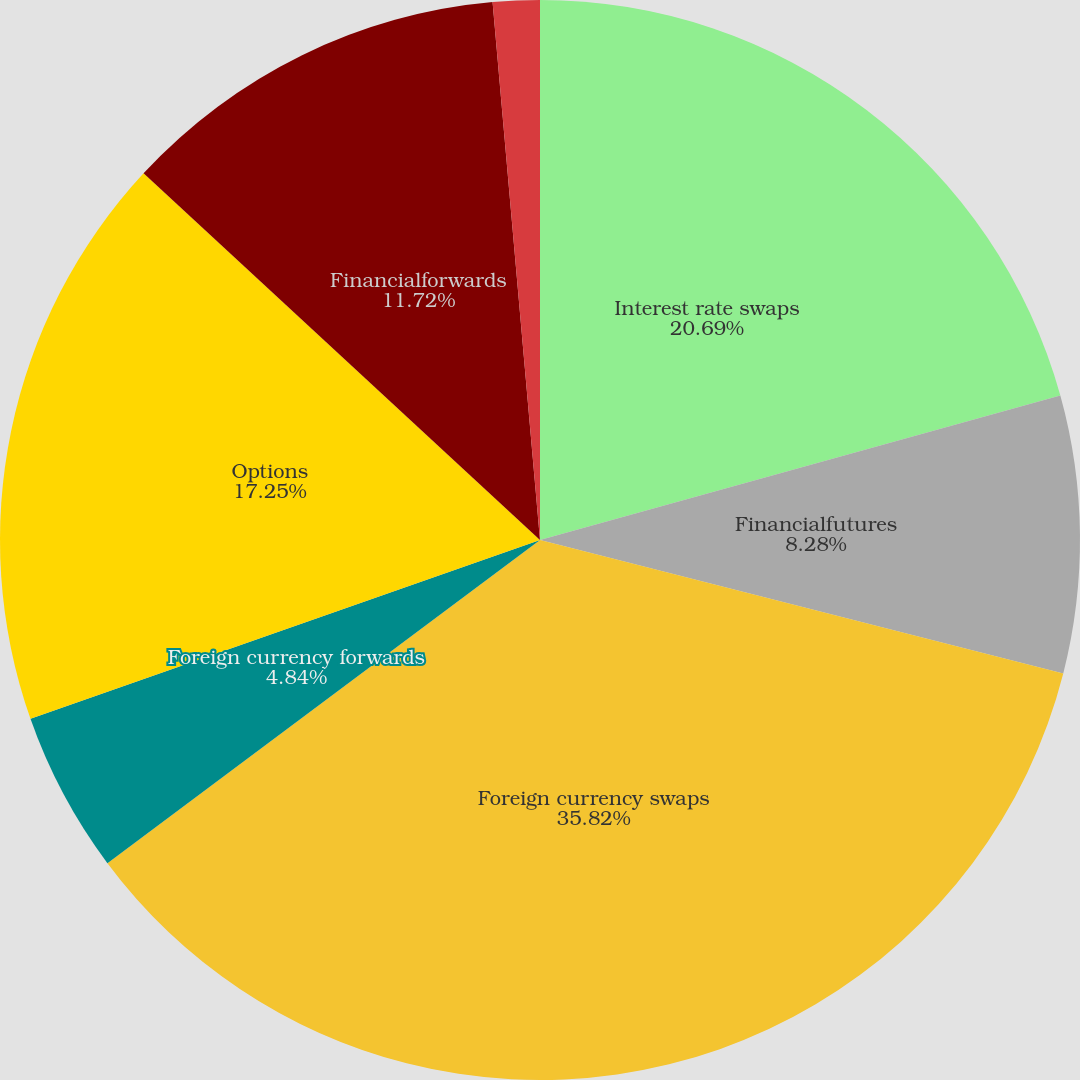Convert chart. <chart><loc_0><loc_0><loc_500><loc_500><pie_chart><fcel>Interest rate swaps<fcel>Financialfutures<fcel>Foreign currency swaps<fcel>Foreign currency forwards<fcel>Options<fcel>Financialforwards<fcel>Creditdefaultswaps<nl><fcel>20.69%<fcel>8.28%<fcel>35.81%<fcel>4.84%<fcel>17.25%<fcel>11.72%<fcel>1.4%<nl></chart> 